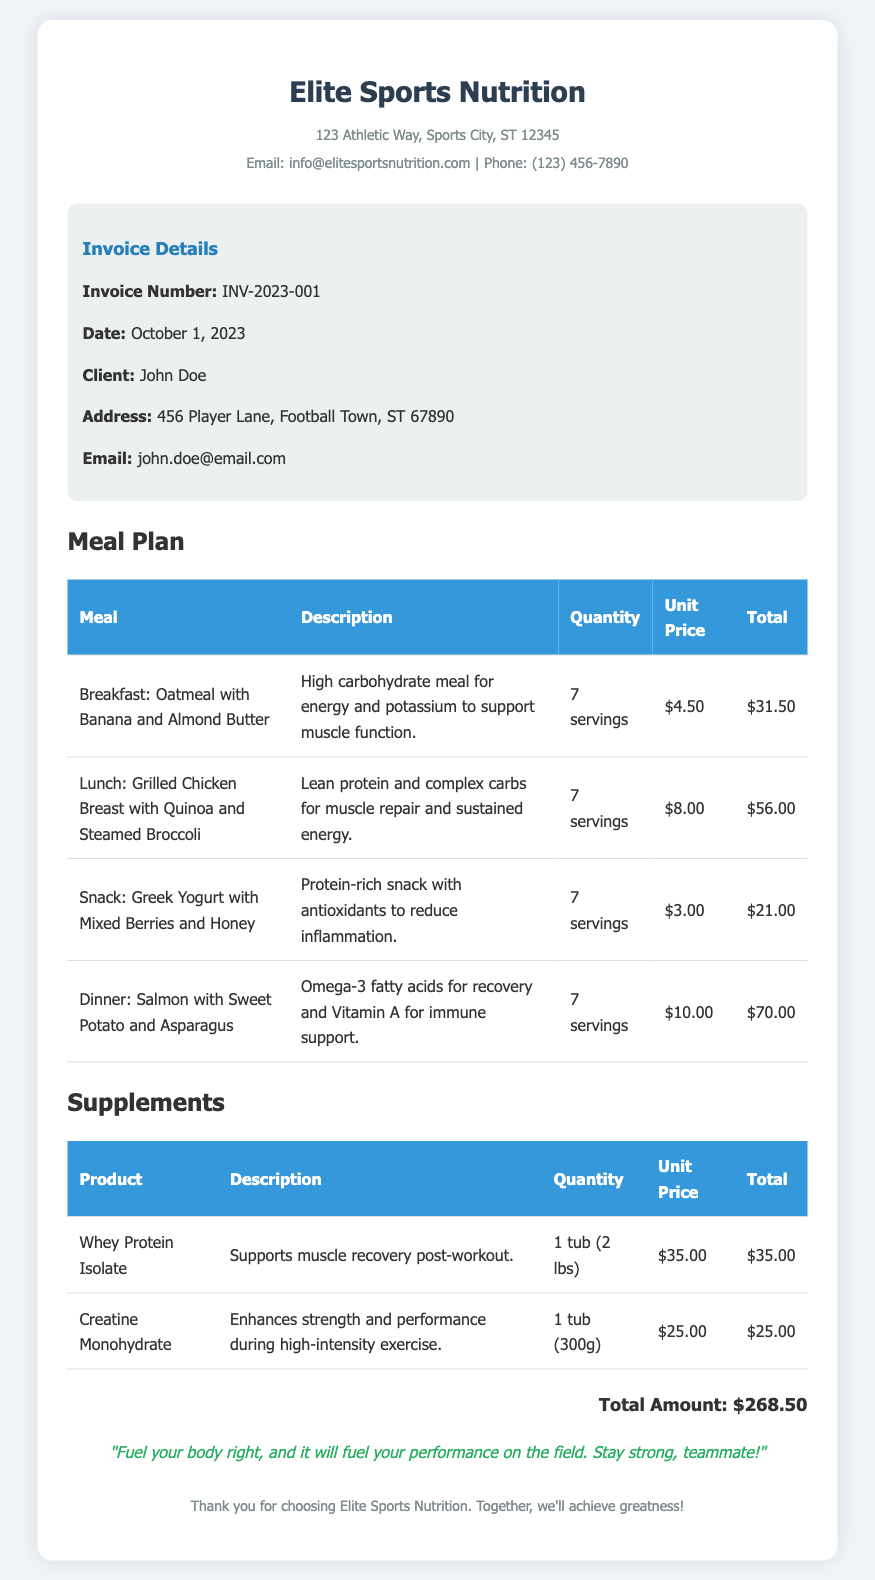What is the invoice number? The invoice number is a unique identifier for the transaction, found in the document.
Answer: INV-2023-001 Who is the client? The client's name is mentioned in the document under the client information section.
Answer: John Doe What is the total amount? The total amount calculates the sum of meals and supplements listed in the invoice.
Answer: $268.50 How many servings of breakfast are included? The number of servings for breakfast is specified in the meal plan table.
Answer: 7 servings What product supports muscle recovery post-workout? The document lists a specific supplement intended for muscle recovery in the supplements section.
Answer: Whey Protein Isolate What meal provides Omega-3 fatty acids? The meal plan table describes which meal includes Omega-3 fatty acids in its ingredients.
Answer: Dinner: Salmon with Sweet Potato and Asparagus How much does Creatine Monohydrate cost? The unit price for the Creatine Monohydrate is provided in the supplements section of the document.
Answer: $25.00 What is the primary benefit of Greek Yogurt with Mixed Berries? The description alongside this snack highlights its nutritional benefits regarding inflammation.
Answer: Reduces inflammation What is the address of Elite Sports Nutrition? The address is provided at the top of the document for the nutrition service.
Answer: 123 Athletic Way, Sports City, ST 12345 